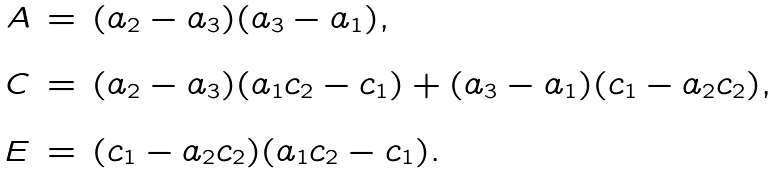Convert formula to latex. <formula><loc_0><loc_0><loc_500><loc_500>\begin{array} { r c l } A & = & ( a _ { 2 } - a _ { 3 } ) ( a _ { 3 } - a _ { 1 } ) , \\ \ & \ & \ \\ C & = & ( a _ { 2 } - a _ { 3 } ) ( a _ { 1 } c _ { 2 } - c _ { 1 } ) + ( a _ { 3 } - a _ { 1 } ) ( c _ { 1 } - a _ { 2 } c _ { 2 } ) , \\ \ & \ & \ \\ E & = & ( c _ { 1 } - a _ { 2 } c _ { 2 } ) ( a _ { 1 } c _ { 2 } - c _ { 1 } ) . \end{array}</formula> 